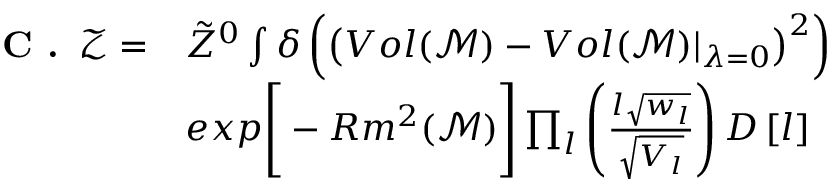<formula> <loc_0><loc_0><loc_500><loc_500>\begin{array} { r l } { C . \, \mathcal { Z } = } & { \tilde { Z } ^ { 0 } \int \delta \left ( \left ( V o l ( \mathcal { M } ) - V o l ( \mathcal { M } ) | _ { \lambda = 0 } \right ) ^ { 2 } \right ) } \\ & { e x p \left [ - R m ^ { 2 } ( \mathcal { M } ) \right ] \prod _ { l } \left ( \frac { l \sqrt { w _ { l } } } { \sqrt { V _ { l } } } \right ) D \left [ l \right ] } \end{array}</formula> 